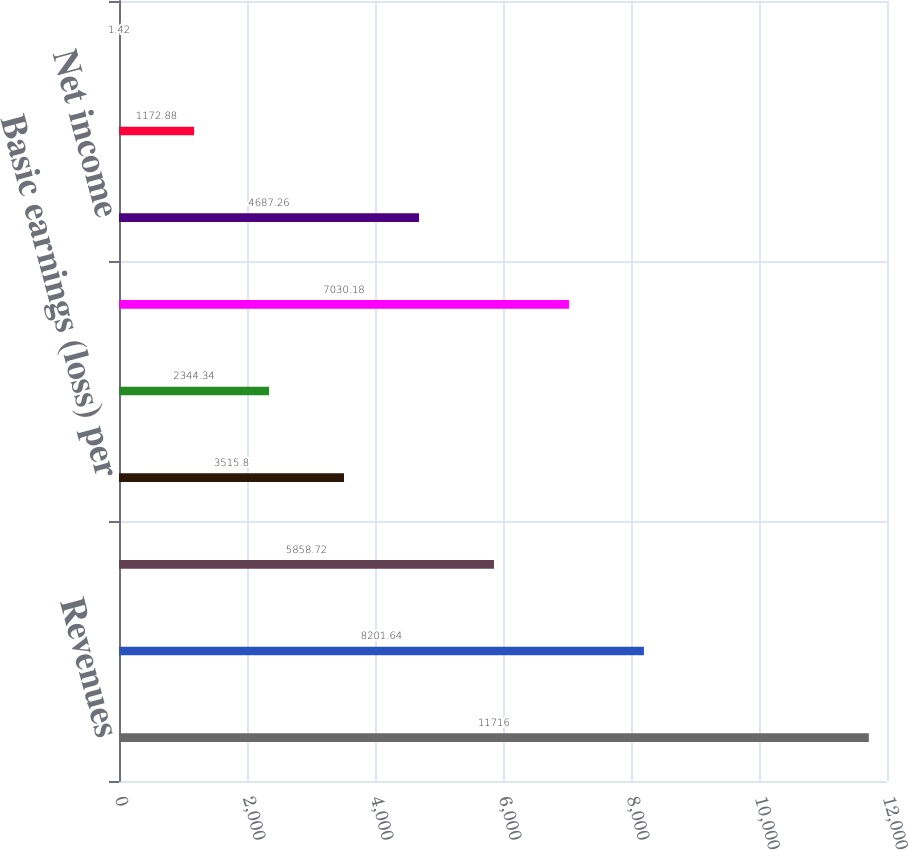<chart> <loc_0><loc_0><loc_500><loc_500><bar_chart><fcel>Revenues<fcel>Operating income (loss)<fcel>Net income (loss)<fcel>Basic earnings (loss) per<fcel>Diluted earnings (loss) per<fcel>Operating income<fcel>Net income<fcel>Basic earnings per common<fcel>Diluted earnings per common<nl><fcel>11716<fcel>8201.64<fcel>5858.72<fcel>3515.8<fcel>2344.34<fcel>7030.18<fcel>4687.26<fcel>1172.88<fcel>1.42<nl></chart> 